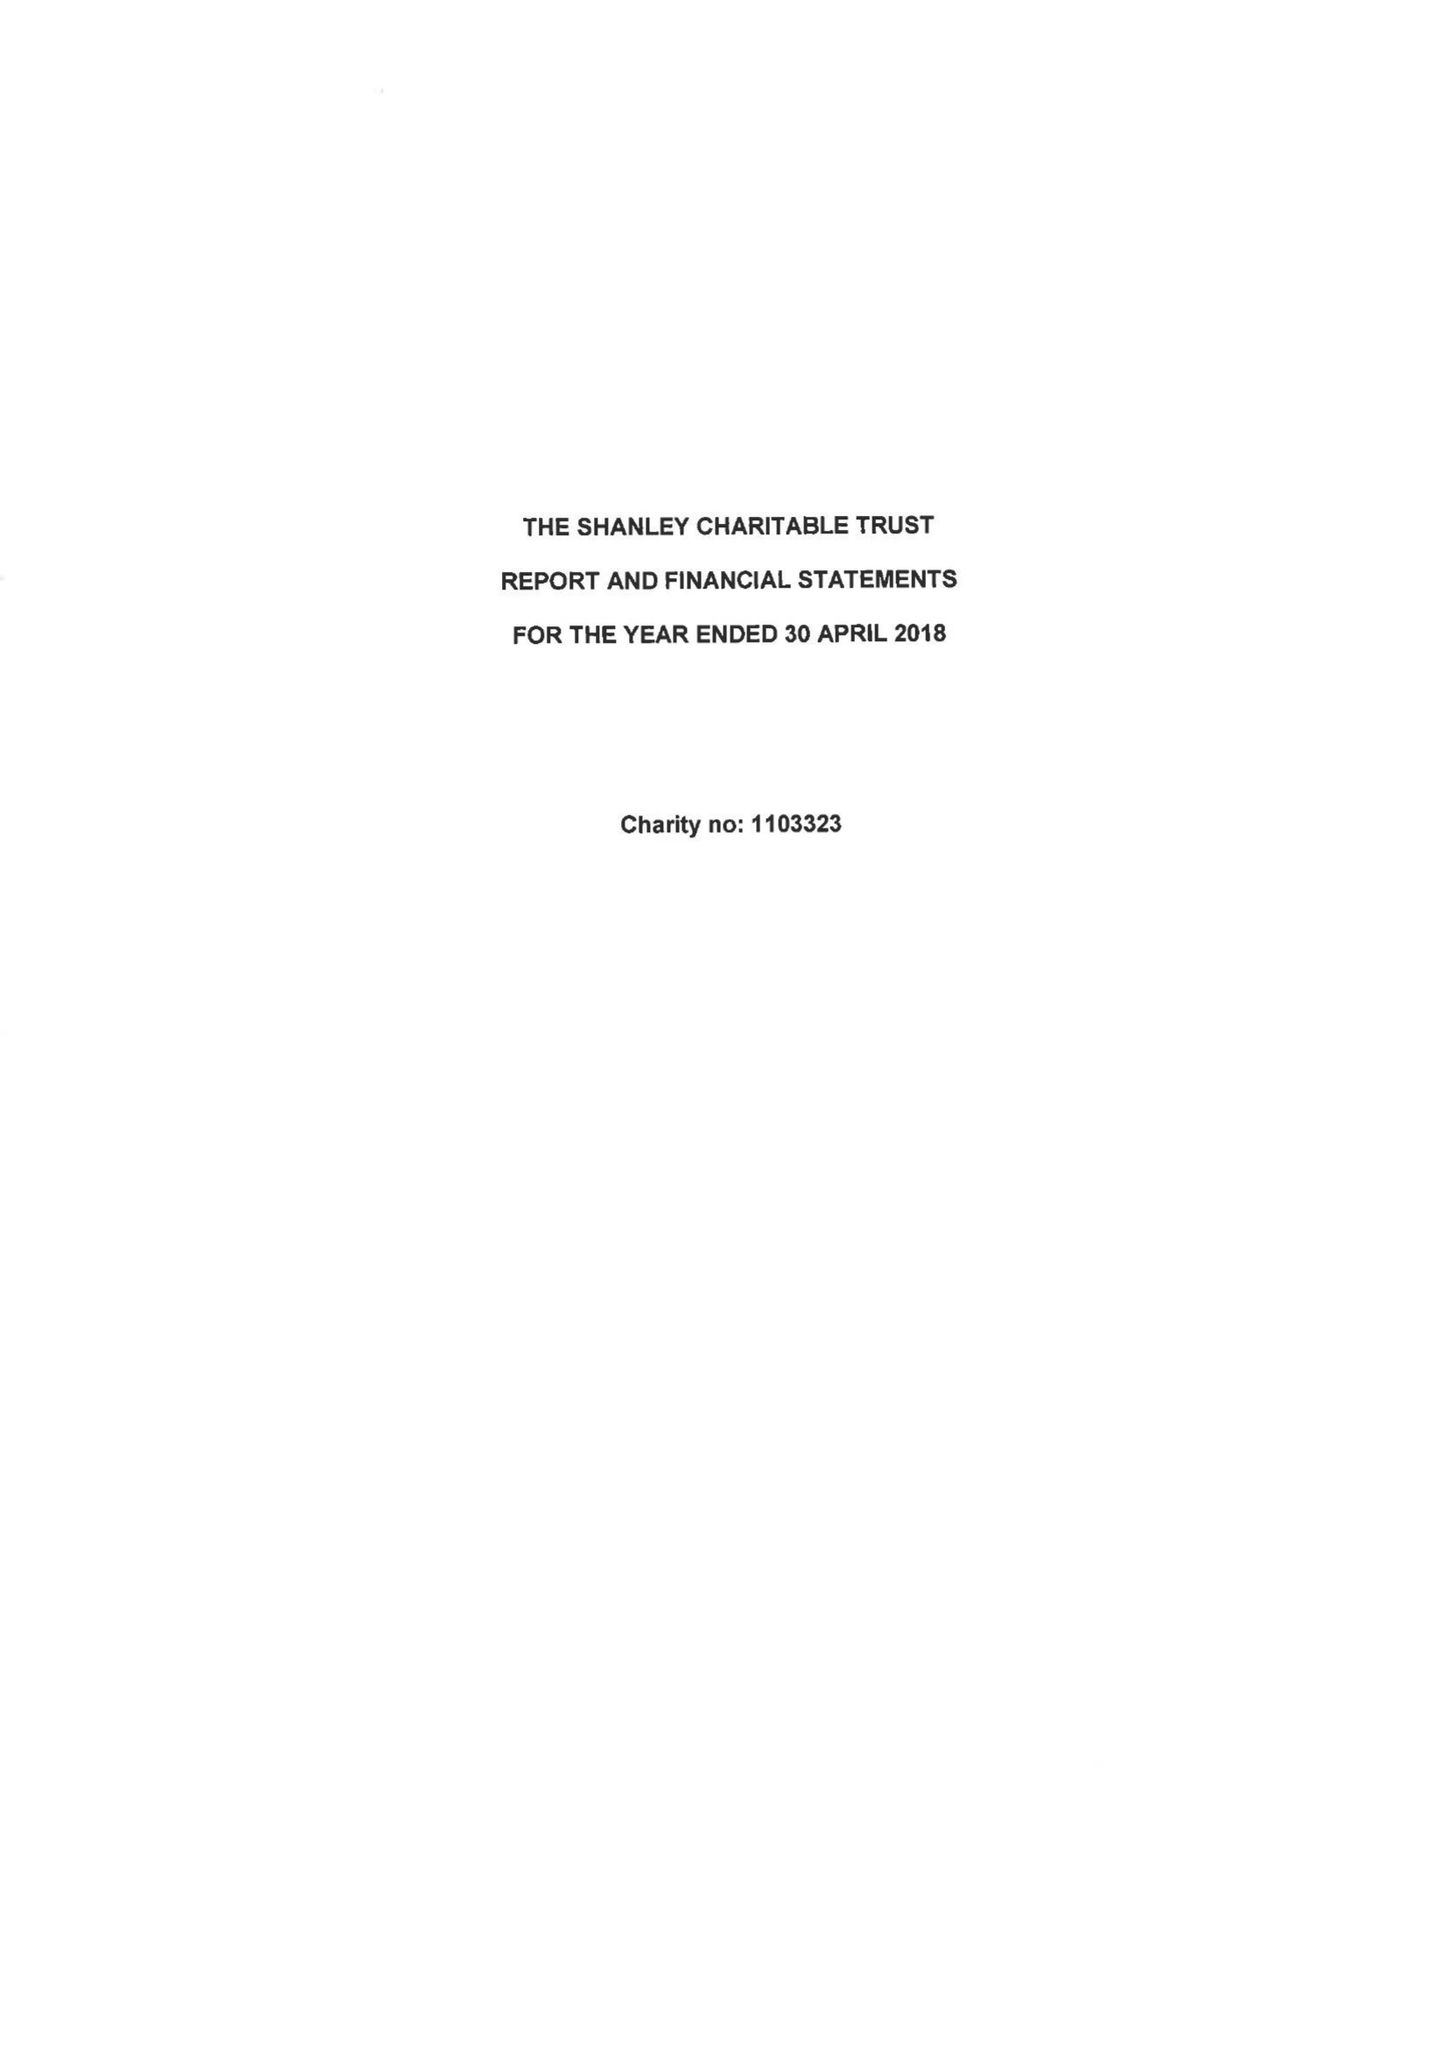What is the value for the spending_annually_in_british_pounds?
Answer the question using a single word or phrase. 119905.00 